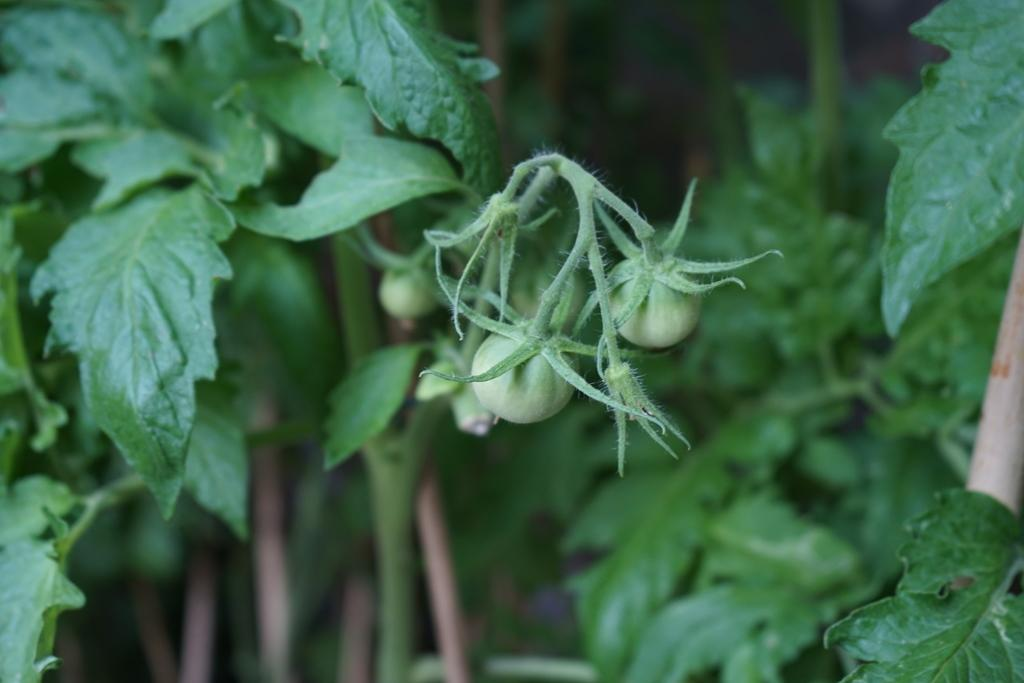What type of food can be seen in the image? There are raw tomatoes in the image. What part of the tomato is visible in the image? There is a stem in the image. What type of vegetation is present in the image? There are leaves in the image. What type of force can be seen in the image? There is no force present in the image; it features raw tomatoes, a stem, and leaves. How does the image promote peace? The image does not promote peace, as it is a simple depiction of raw tomatoes, a stem, and leaves. 